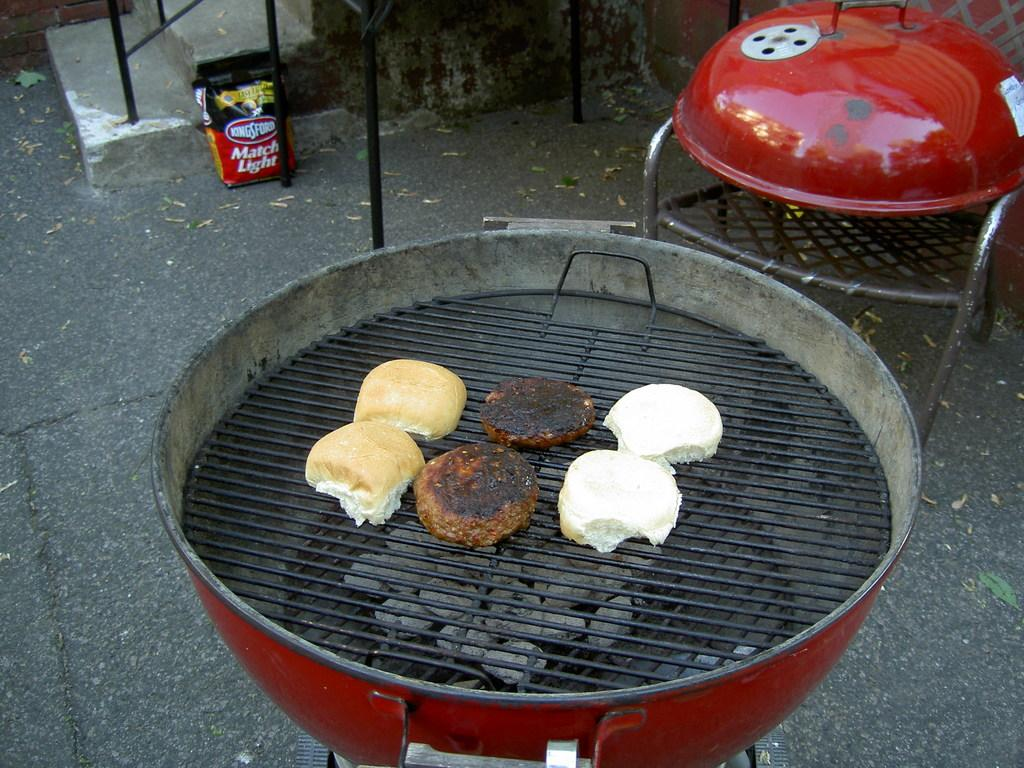<image>
Present a compact description of the photo's key features. A bag of Kingsford Match Light is on the ground near a barbeque. 